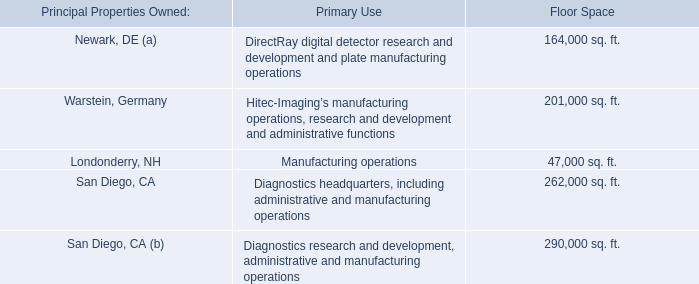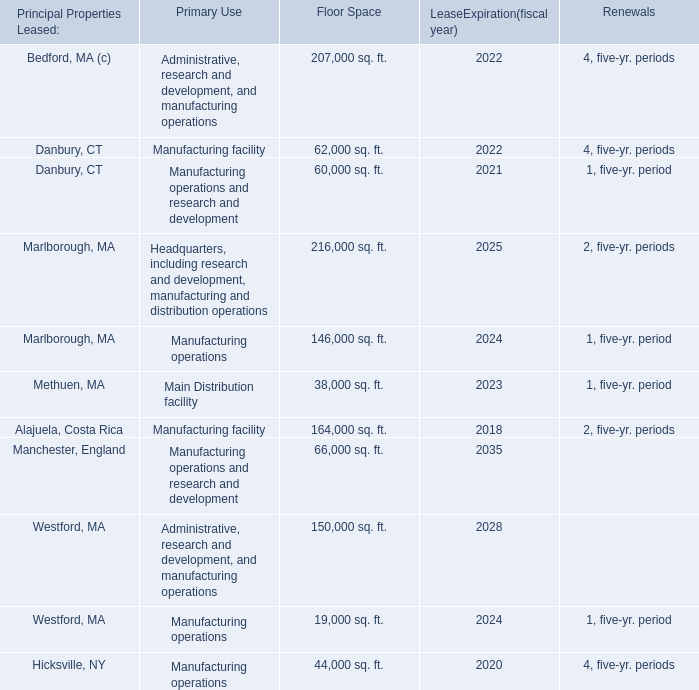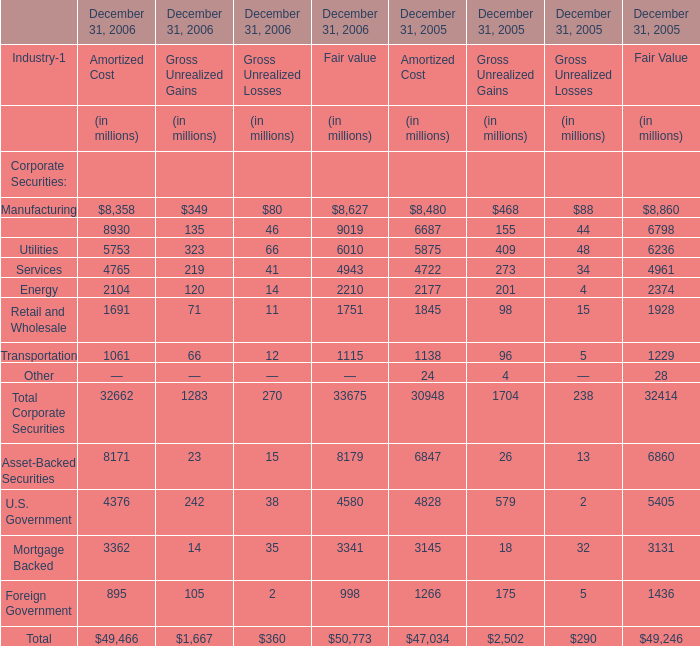As As the chart 2 shows,which year is the Gross Unrealized Gains for Total Corporate Securities on December 31 greater than 1700 million? 
Answer: 2005. 